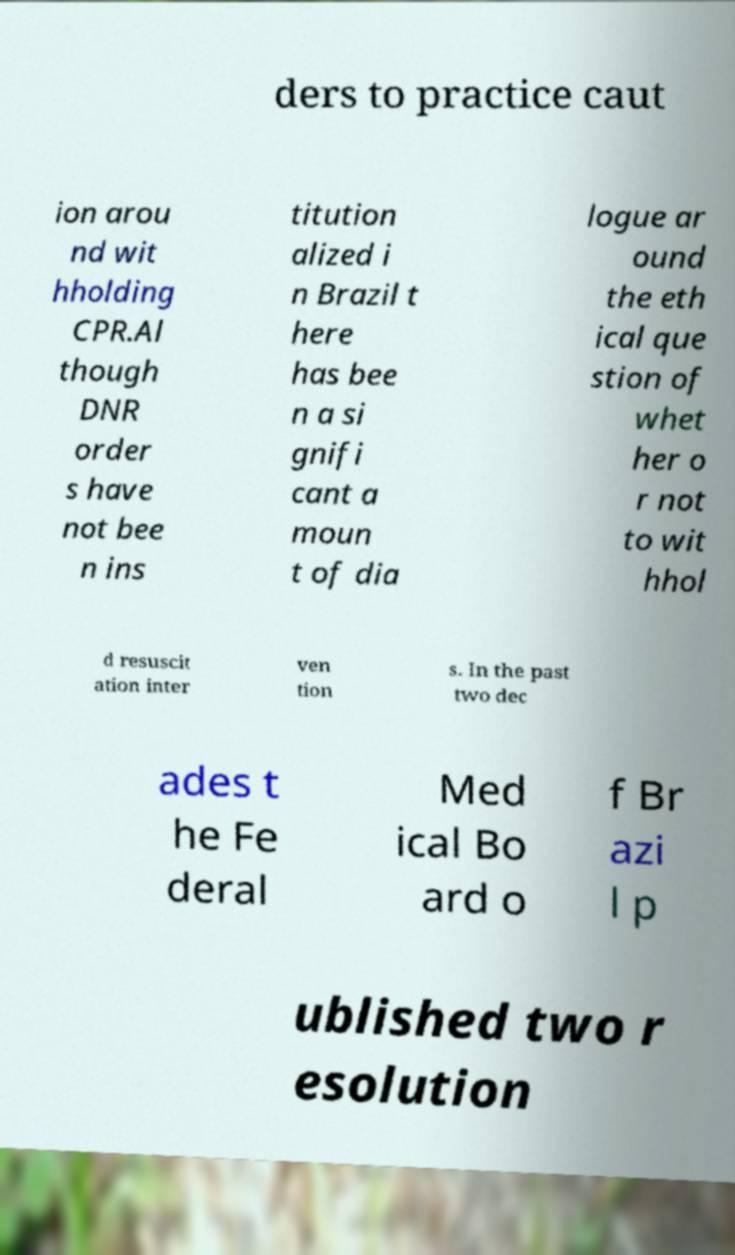For documentation purposes, I need the text within this image transcribed. Could you provide that? ders to practice caut ion arou nd wit hholding CPR.Al though DNR order s have not bee n ins titution alized i n Brazil t here has bee n a si gnifi cant a moun t of dia logue ar ound the eth ical que stion of whet her o r not to wit hhol d resuscit ation inter ven tion s. In the past two dec ades t he Fe deral Med ical Bo ard o f Br azi l p ublished two r esolution 